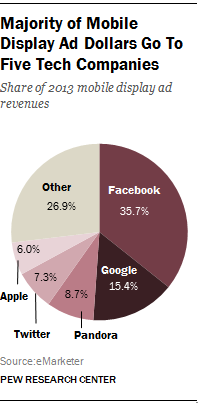Mention a couple of crucial points in this snapshot. The total revenue generated by Apple, Twitter, and Pandora is greater than Google's share of ad revenue. The third largest contributor in the graph is Google. 